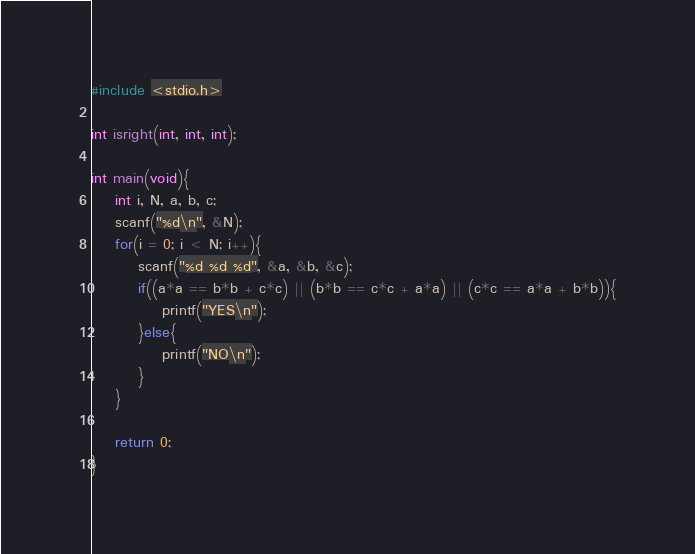<code> <loc_0><loc_0><loc_500><loc_500><_C_>#include <stdio.h>

int isright(int, int, int);

int main(void){
	int i, N, a, b, c;
	scanf("%d\n", &N);
	for(i = 0; i < N; i++){
		scanf("%d %d %d", &a, &b, &c);
		if((a*a == b*b + c*c) || (b*b == c*c + a*a) || (c*c == a*a + b*b)){
			printf("YES\n");
		}else{
			printf("NO\n");
		}
	}
	
	return 0;	
}</code> 